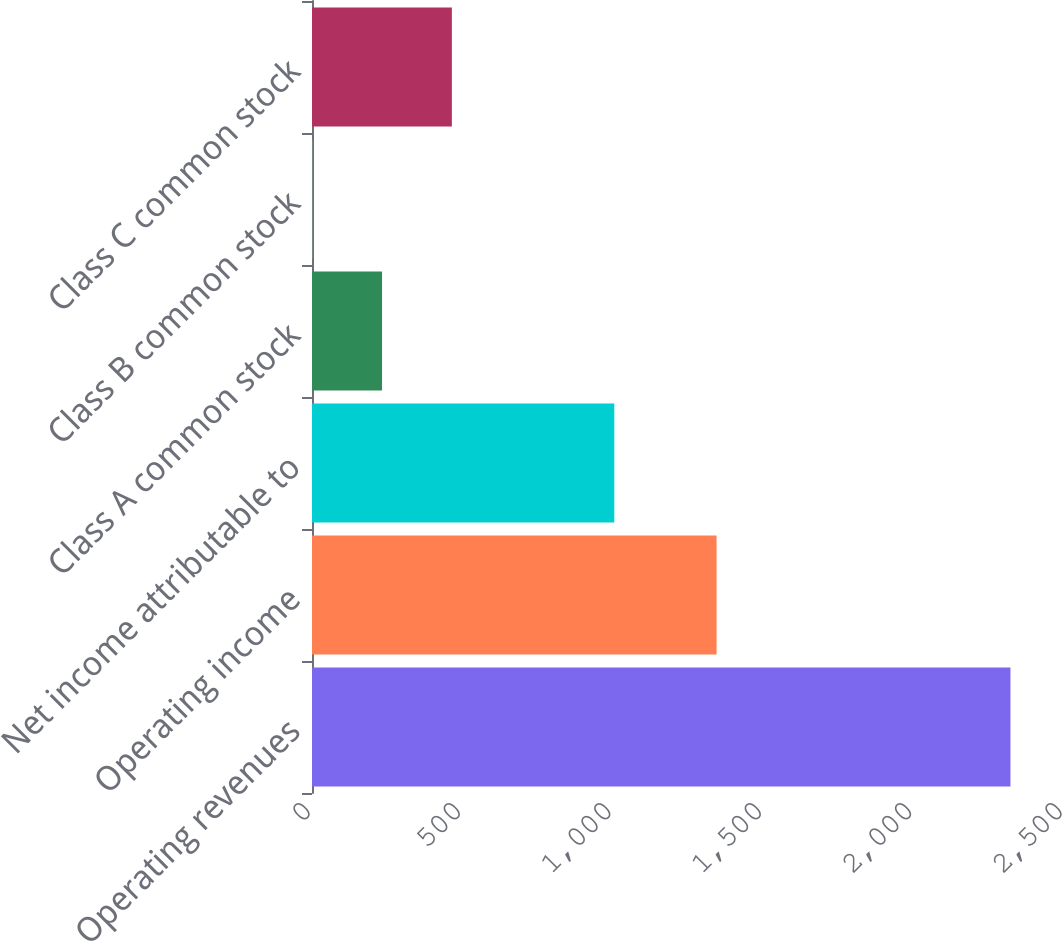Convert chart to OTSL. <chart><loc_0><loc_0><loc_500><loc_500><bar_chart><fcel>Operating revenues<fcel>Operating income<fcel>Net income attributable to<fcel>Class A common stock<fcel>Class B common stock<fcel>Class C common stock<nl><fcel>2322<fcel>1345<fcel>1005<fcel>232.83<fcel>0.7<fcel>464.96<nl></chart> 